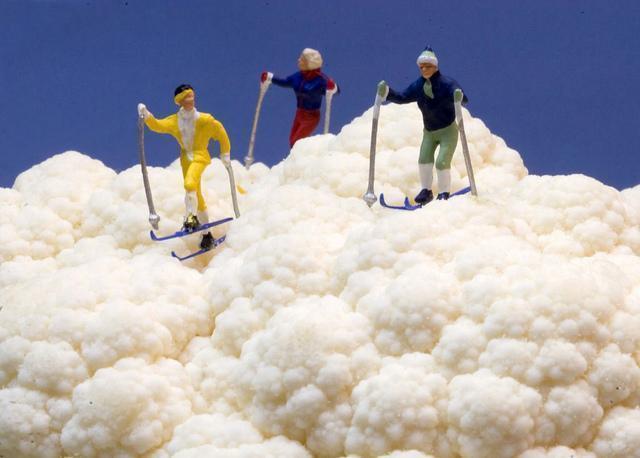What material was used to depict the snow in this art piece?
Pick the correct solution from the four options below to address the question.
Options: Bubbles, cotton, feathers, yarn. Cotton. 